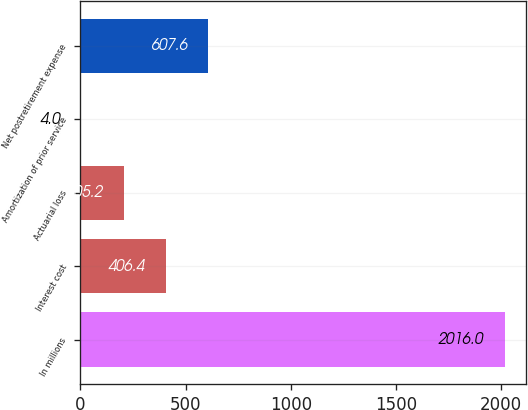<chart> <loc_0><loc_0><loc_500><loc_500><bar_chart><fcel>In millions<fcel>Interest cost<fcel>Actuarial loss<fcel>Amortization of prior service<fcel>Net postretirement expense<nl><fcel>2016<fcel>406.4<fcel>205.2<fcel>4<fcel>607.6<nl></chart> 